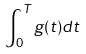Convert formula to latex. <formula><loc_0><loc_0><loc_500><loc_500>\int _ { 0 } ^ { T } g ( t ) d t</formula> 